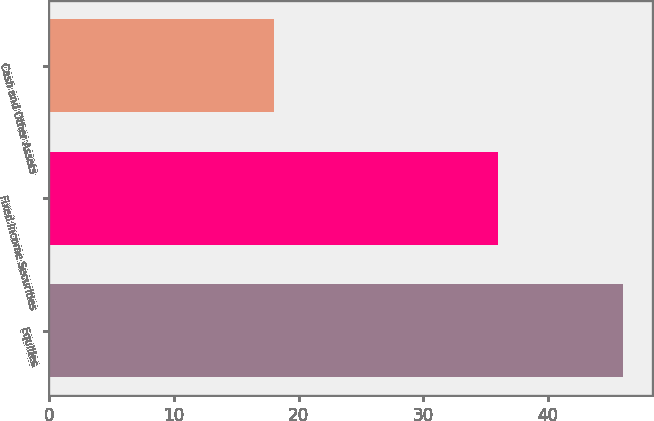<chart> <loc_0><loc_0><loc_500><loc_500><bar_chart><fcel>Equities<fcel>Fixed Income Securities<fcel>Cash and Other Assets<nl><fcel>46<fcel>36<fcel>18<nl></chart> 